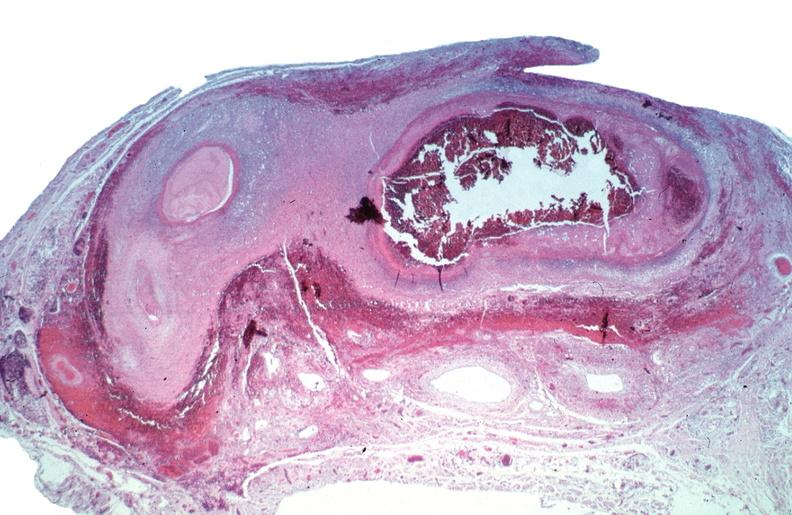does this image show vasculitis, polyarteritis nodosa?
Answer the question using a single word or phrase. Yes 